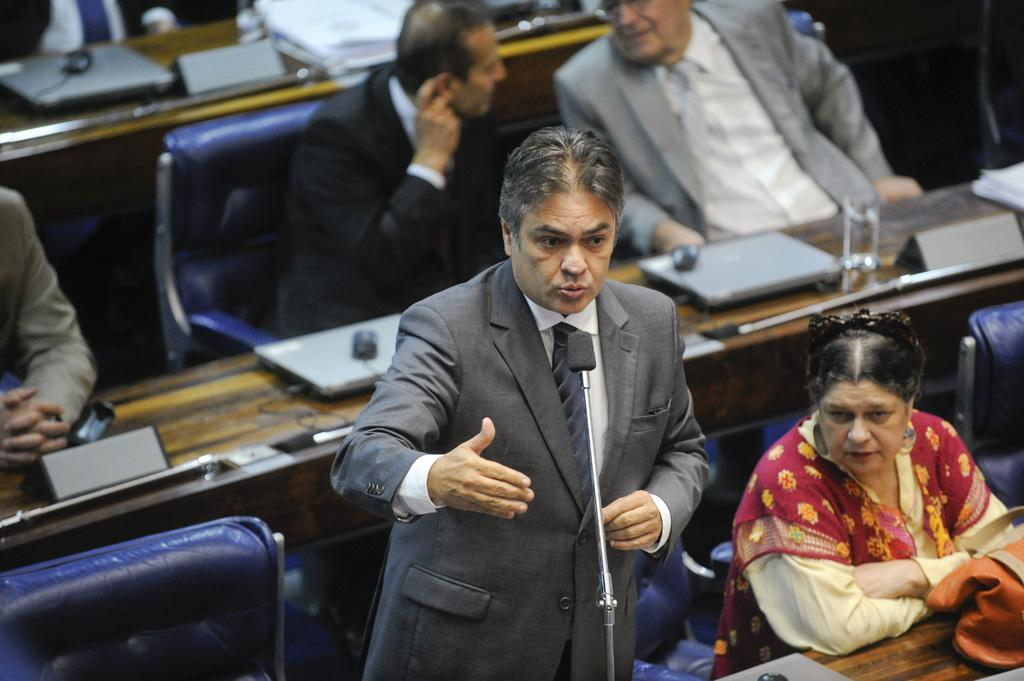What is the position of the man in the image? There is a man standing at the bottom of the image. What are the people in the background doing? The people are sitting on chairs in the background. What electronic devices can be seen on the tables? Laptops are present on the tables. What else can be found on the tables besides laptops? Other objects are kept on the tables. How many nails are being hammered into the bulb in the image? There is no nail or bulb present in the image. 